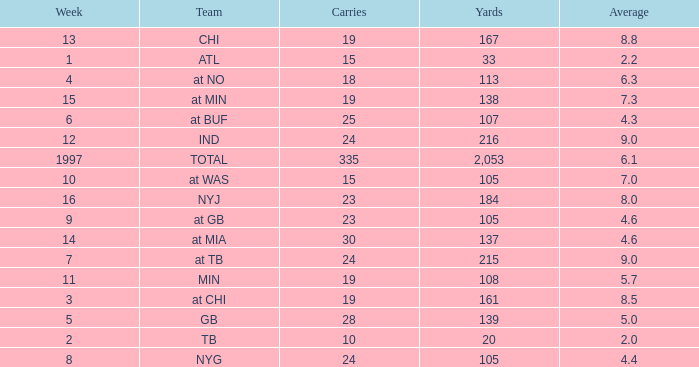Which Yards have Carries smaller than 23, and a Team of at chi, and an Average smaller than 8.5? None. 